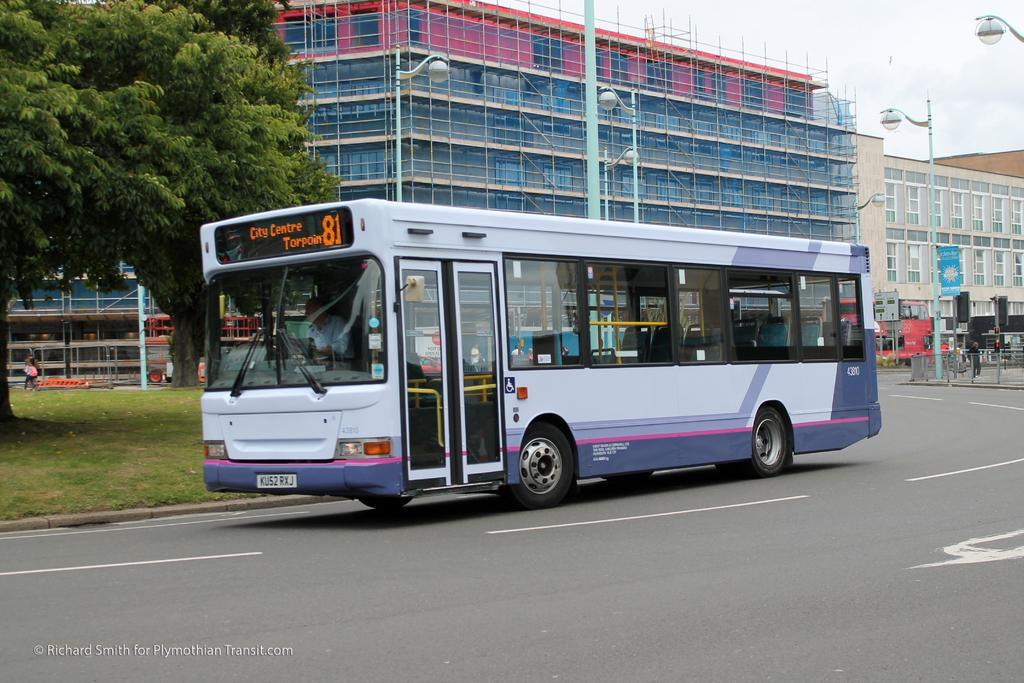<image>
Offer a succinct explanation of the picture presented. the number 81 bus going to city centre torpoin 